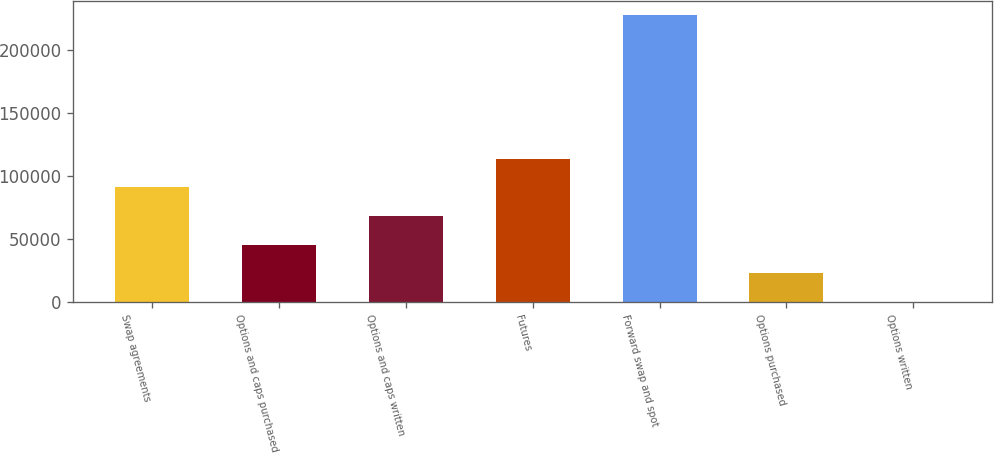<chart> <loc_0><loc_0><loc_500><loc_500><bar_chart><fcel>Swap agreements<fcel>Options and caps purchased<fcel>Options and caps written<fcel>Futures<fcel>Forward swap and spot<fcel>Options purchased<fcel>Options written<nl><fcel>91194.4<fcel>45665.2<fcel>68429.8<fcel>113959<fcel>227782<fcel>22900.6<fcel>136<nl></chart> 